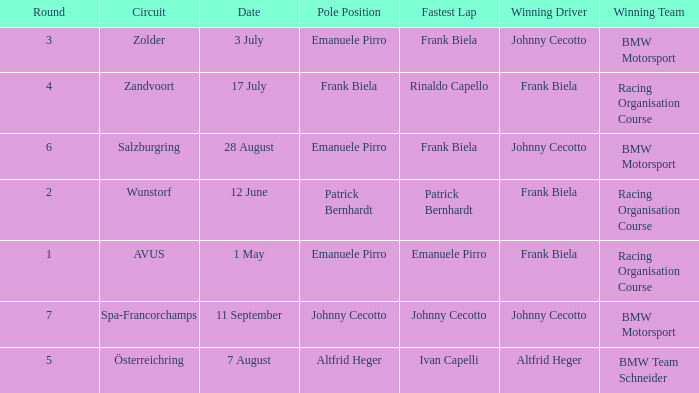Who was the winning team on the circuit Zolder? BMW Motorsport. 